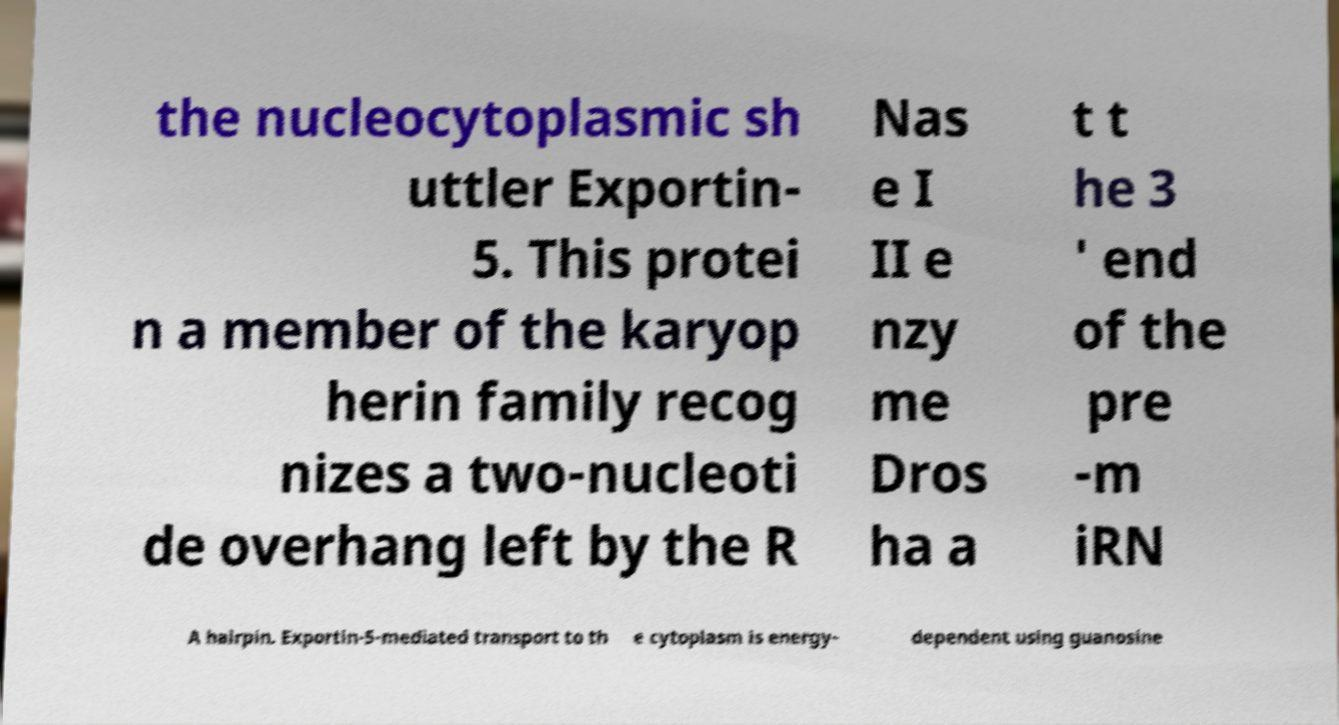Could you extract and type out the text from this image? the nucleocytoplasmic sh uttler Exportin- 5. This protei n a member of the karyop herin family recog nizes a two-nucleoti de overhang left by the R Nas e I II e nzy me Dros ha a t t he 3 ' end of the pre -m iRN A hairpin. Exportin-5-mediated transport to th e cytoplasm is energy- dependent using guanosine 